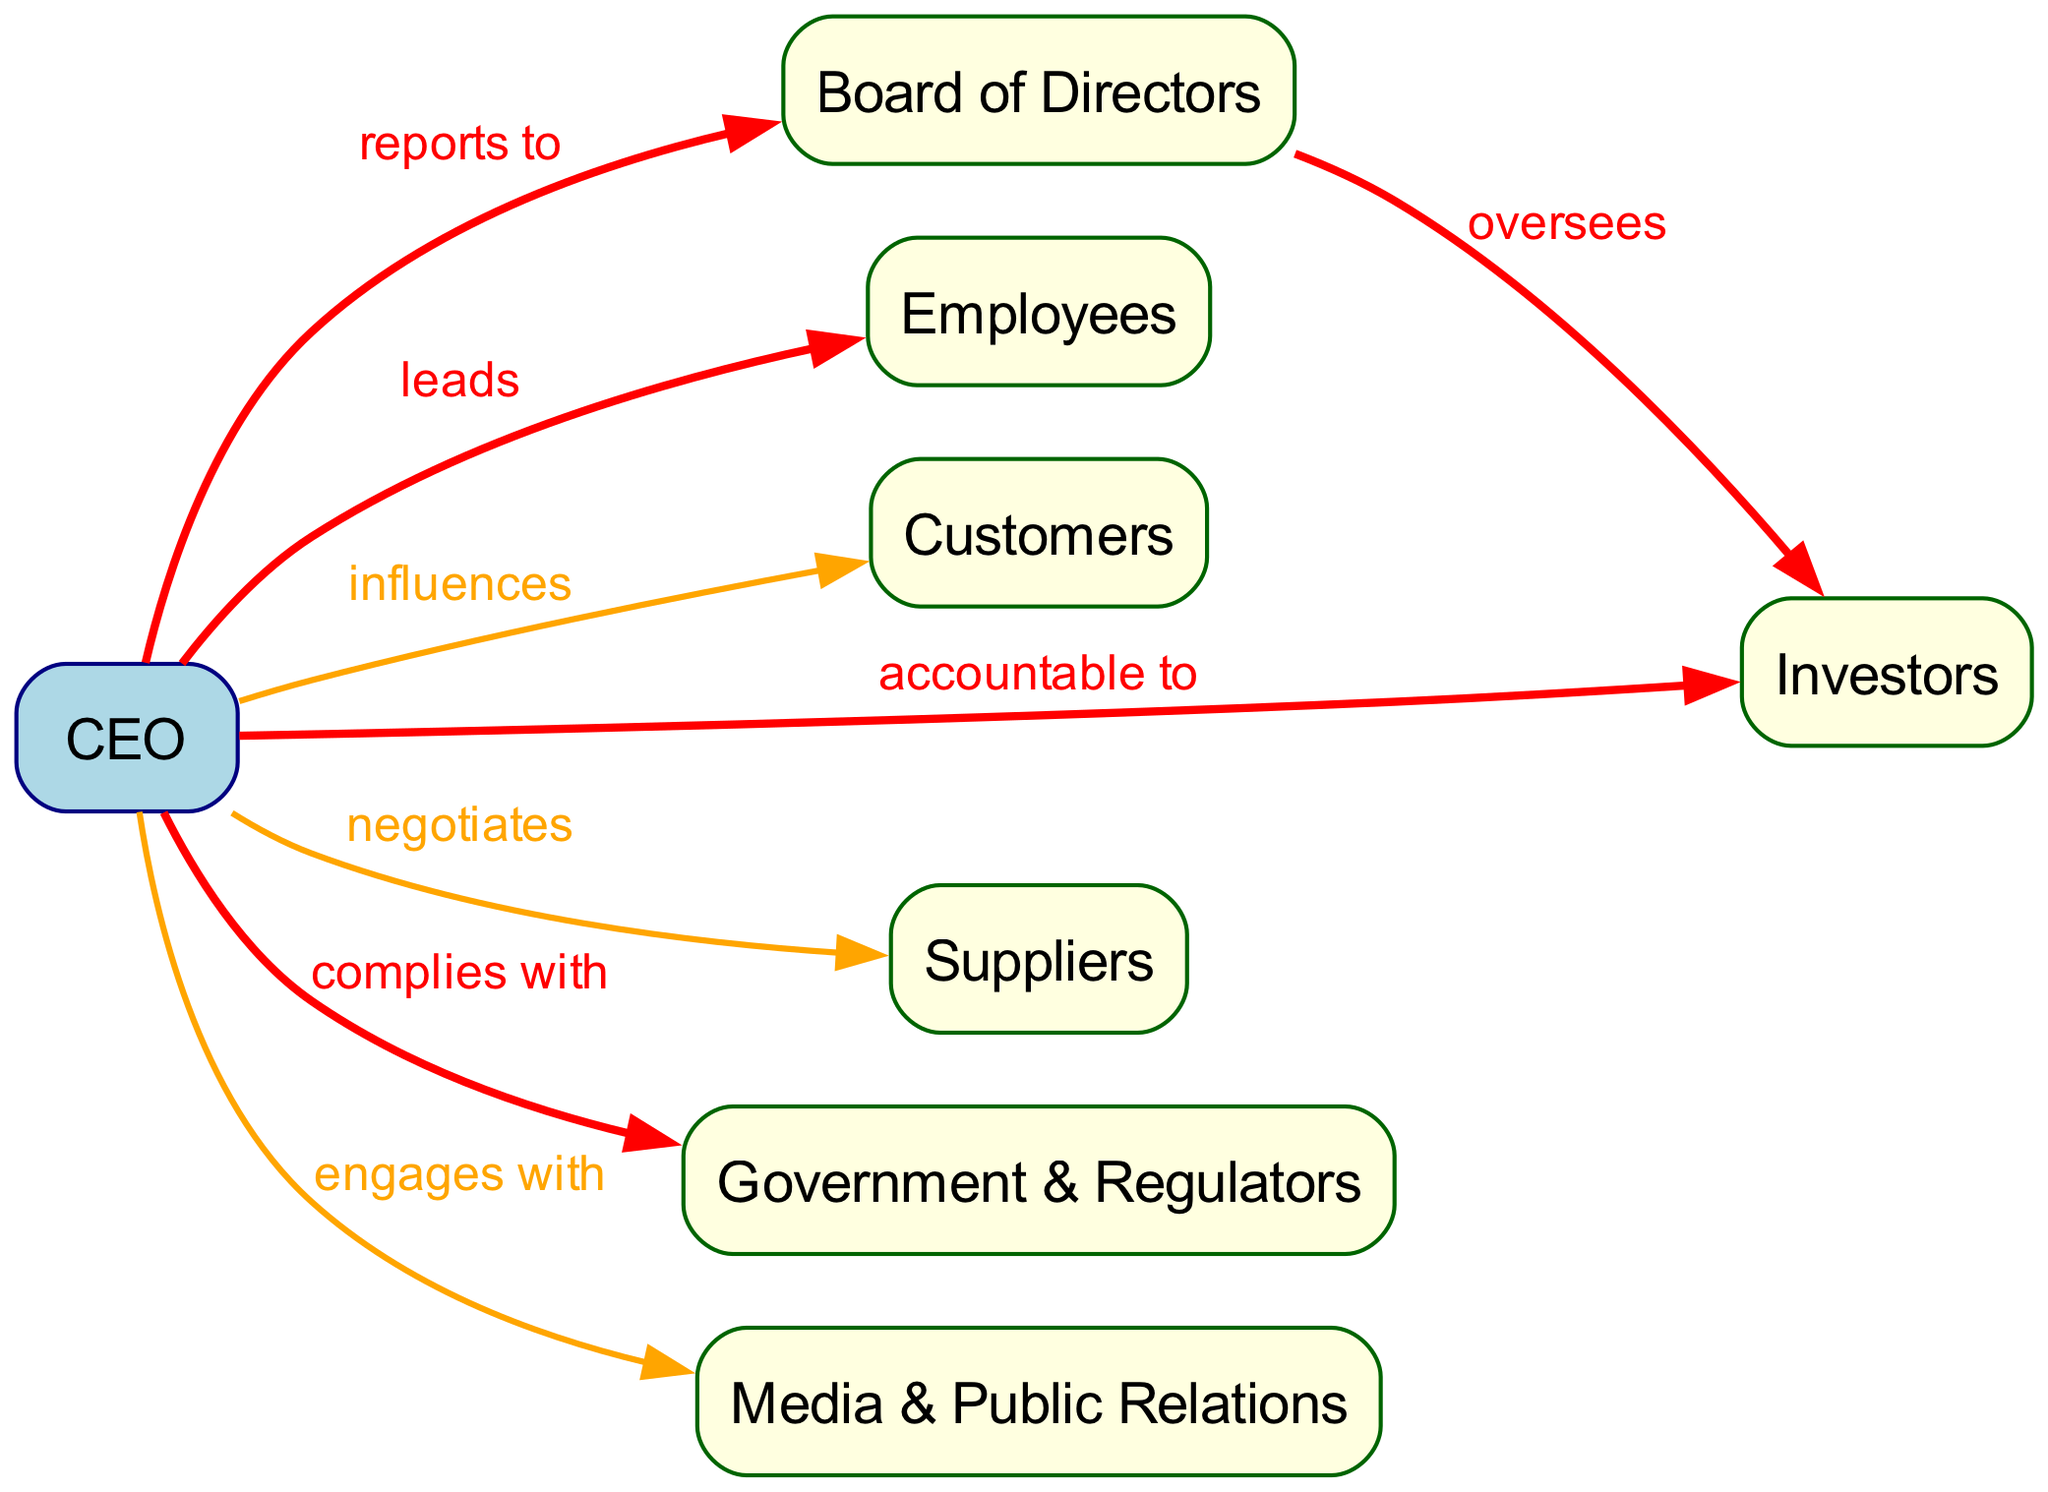What is the relationship between the CEO and the Board of Directors? The relationship between the CEO and the Board of Directors is labeled as "reports to," indicating that the CEO is accountable to the board for their performance and decisions.
Answer: reports to How many stakeholders are displayed in the diagram? The diagram lists six stakeholders: Employees, Customers, Investors, Suppliers, Government & Regulators, and Media & Public Relations. Therefore, the total number of stakeholders is six.
Answer: 6 What is the impact level of the relationship between the CEO and Investors? The diagram shows that the impact level of the relationship between the CEO and Investors is classified as "high." This indicates that there is a significant influence the CEO has on this group.
Answer: high Which stakeholder does the CEO lead? According to the diagram, the CEO leads the Employees, as indicated by the "leads" relationship connecting these two nodes.
Answer: Employees How is the relationship between the Board of Directors and Investors characterized? The relationship between the Board of Directors and Investors is described with the label "oversees," indicating that the board has a supervisory role over the investors.
Answer: oversees Which stakeholder has a medium impact level relationship with the CEO for negotiations? The medium impact level relationship with the CEO for negotiations is with the Suppliers, as identified in the diagram where this connection exists.
Answer: Suppliers In total, how many edges are present in the diagram? The diagram features seven edges that represent the relationships between the CEO and various stakeholders.
Answer: 7 Which stakeholder group does the CEO engage with? The CEO engages with Media & Public Relations, as shown by the diagram indicating an "engages with" relationship with this stakeholder group.
Answer: Media & Public Relations What is the relationship type between the CEO and Government & Regulators? The relationship type between the CEO and Government & Regulators is defined as "complies with," suggesting that the CEO must adhere to regulations and laws set by government bodies.
Answer: complies with 